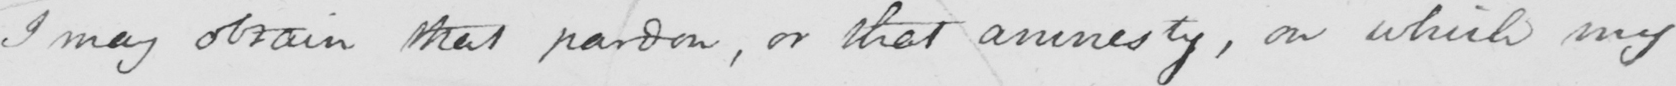What does this handwritten line say? I may obtain that pardon , or that amnesty , on which my 